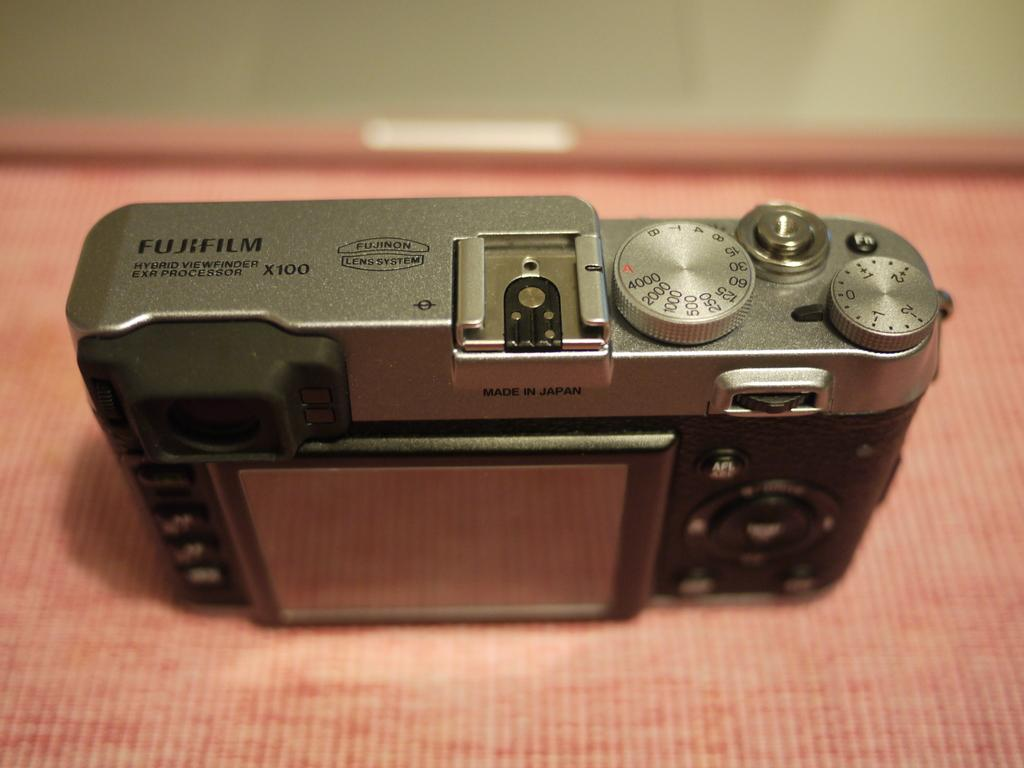What is the main object in the image? There is a camera in the image. Where is the camera positioned? The camera is on a platform. Can you describe the background of the image? The background of the image is blurry. What type of behavior can be observed in the stem of the plant in the image? There is no plant or stem present in the image; it features a camera on a platform with a blurry background. 